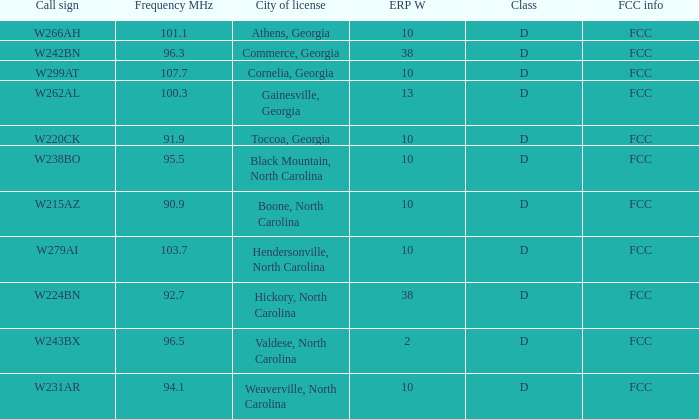What is the Frequency MHz for the station with a call sign of w224bn? 92.7. 